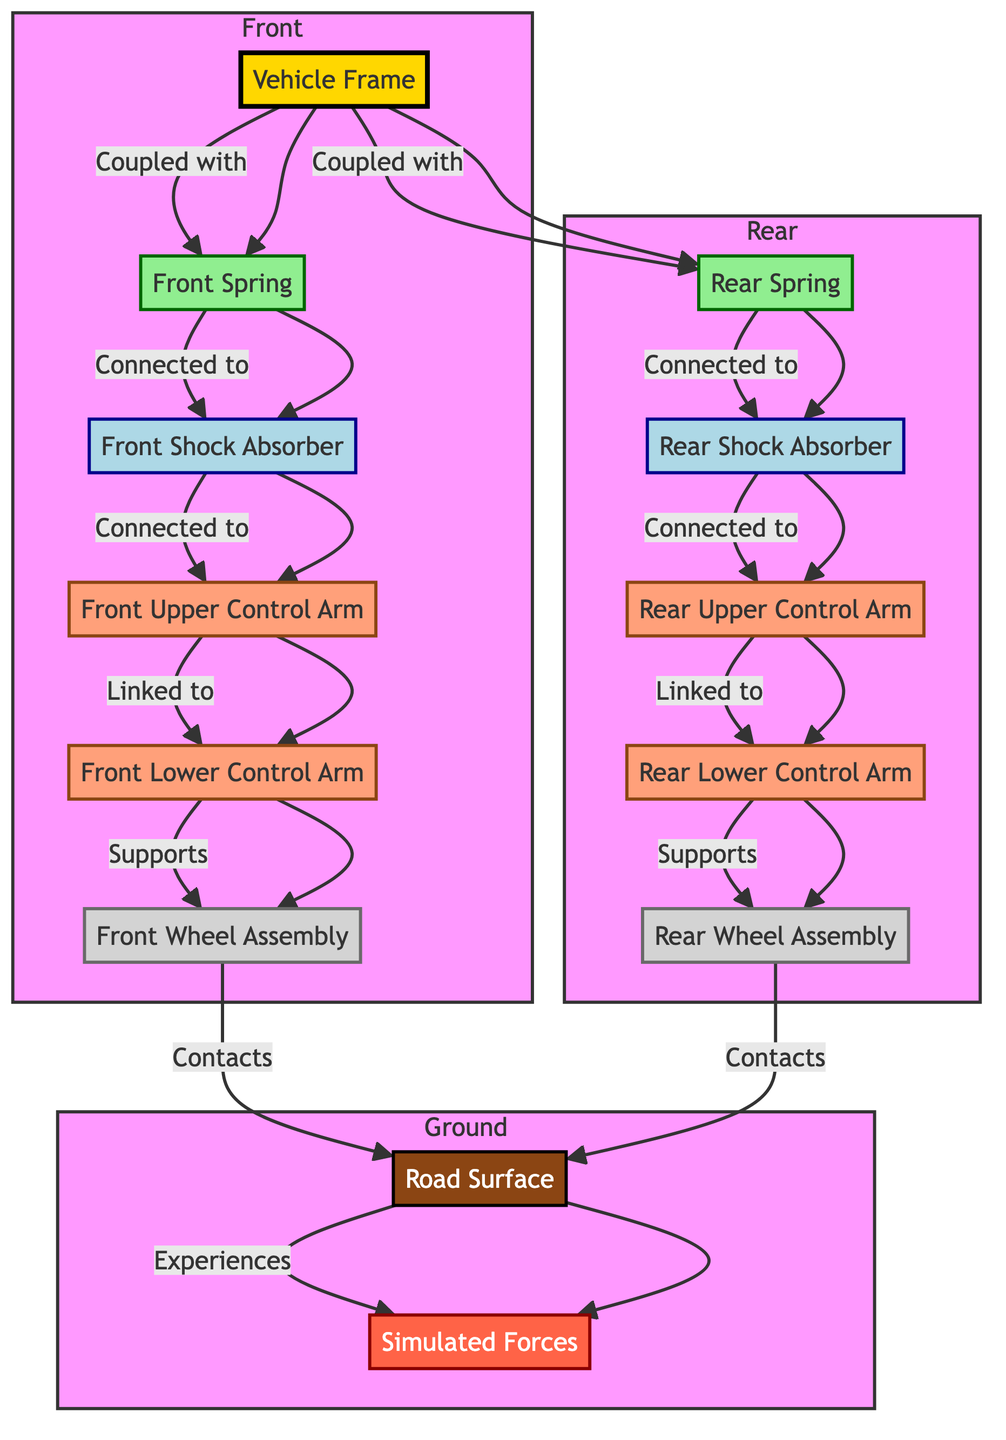How many springs are in the diagram? The diagram includes two spring nodes: one is the front spring and the other is the rear spring. Therefore, counting both gives a total of two springs in the system.
Answer: 2 What does the front wheel assembly support? According to the diagram, the front upper control arm is connected to the front lower control arm, which in turn supports the front wheel assembly, indicating that it supports the components linked to these control arms.
Answer: Front Wheel Assembly Which component is linked to the rear upper control arm? The rear upper control arm is directly connected to the rear shock absorber according to the relationships depicted in the diagram. Hence, it is directly linked to the rear shock absorber.
Answer: Rear Shock Absorber What experiences the simulated forces? The diagram indicates that the road surface experiences the simulated forces, as it is the link between the road and the forces acting on the vehicle. Hence, the road surface is the component that experiences these forces.
Answer: Road Surface Which component is coupled with the vehicle frame? The vehicle frame is coupled with both the front spring and the rear spring, showcasing the primary connections made between the frame and these suspension elements in the diagram.
Answer: Front Spring and Rear Spring How many control arms are represented in the diagram? The diagram contains four control arms: the front upper control arm, front lower control arm, rear upper control arm, and rear lower control arm. Thus, counting all these components gives a total of four control arms.
Answer: 4 What is the connection relationship between the shock absorber front and the control arm front upper? The diagram shows a direct connection between the front shock absorber and the front upper control arm, indicating that the front shock absorber is linked to the front upper control arm.
Answer: Connected to What is the role of the wheel assembly? Each wheel assembly in the diagram contacts the road surface and plays a crucial role as it supports the vehicle's suspension system, acting as the concluding point for the control arms.
Answer: Supports the Vehicle/Suspension System Which elements are classified as "spring" in the diagram? The elements classified as "spring" in the diagram include both the front spring and the rear spring, as indicated by the specific class definitions assigned in the flowchart.
Answer: Front Spring and Rear Spring 